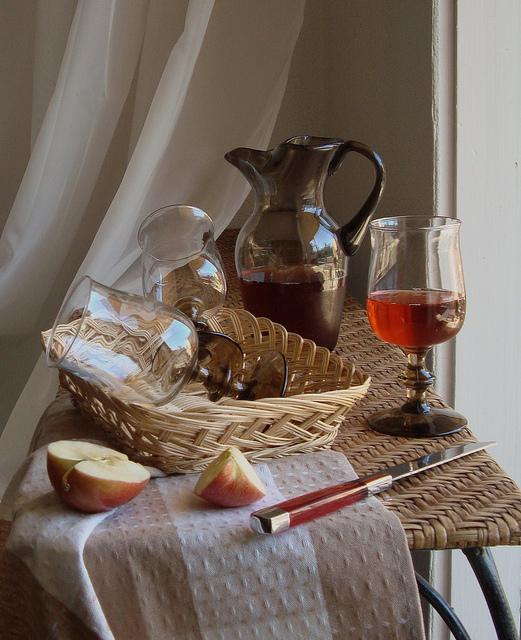What is the table made of?
Concise answer only. Wicker. How many glasses are in the picture?
Be succinct. 3. Is the apple fresh?
Write a very short answer. Yes. Is the glass full?
Short answer required. No. 